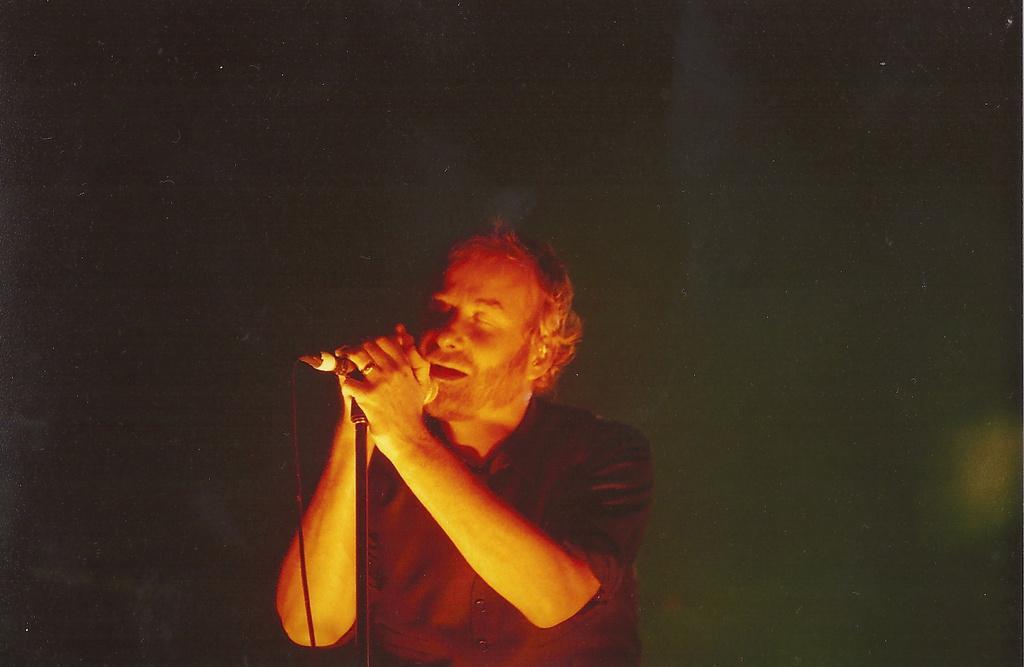How would you summarize this image in a sentence or two? In the center of the image we can see a man standing and holding a mic which is placed on the stand. 